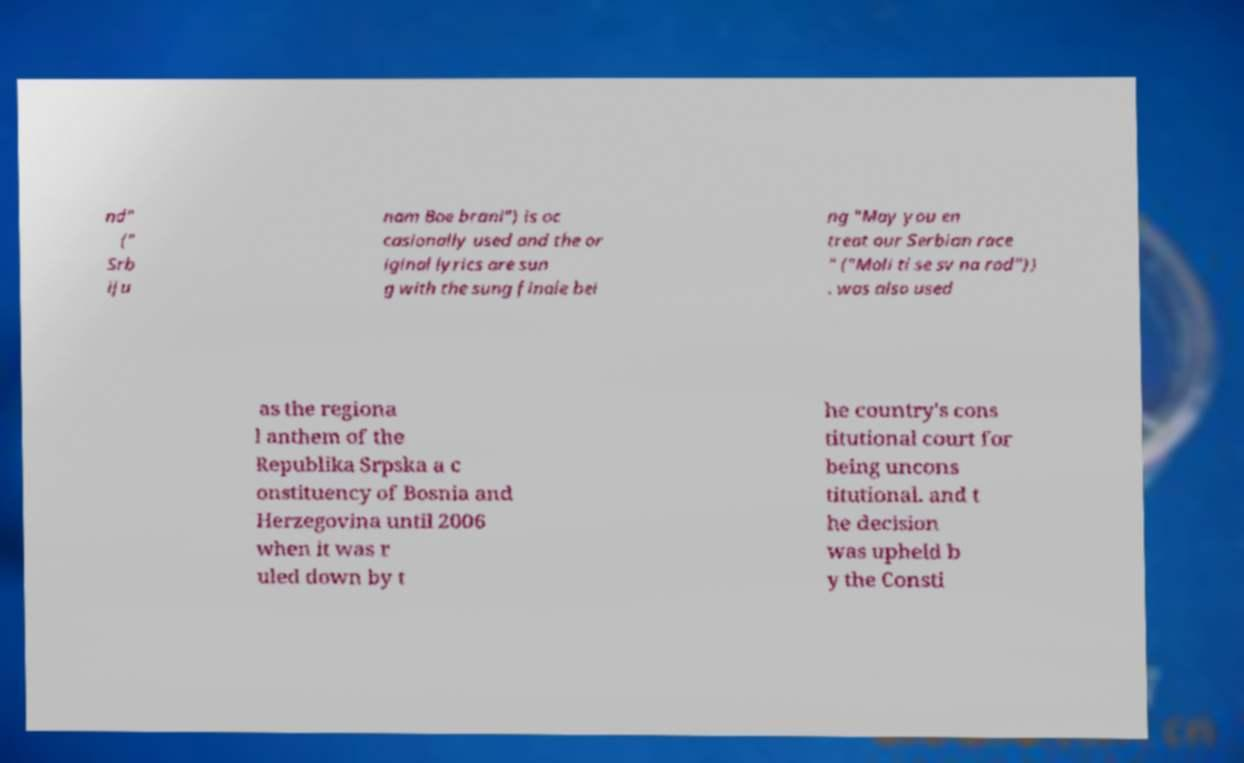What messages or text are displayed in this image? I need them in a readable, typed format. nd" (" Srb iju nam Boe brani") is oc casionally used and the or iginal lyrics are sun g with the sung finale bei ng "May you en treat our Serbian race " ("Moli ti se sv na rod")) . was also used as the regiona l anthem of the Republika Srpska a c onstituency of Bosnia and Herzegovina until 2006 when it was r uled down by t he country's cons titutional court for being uncons titutional. and t he decision was upheld b y the Consti 